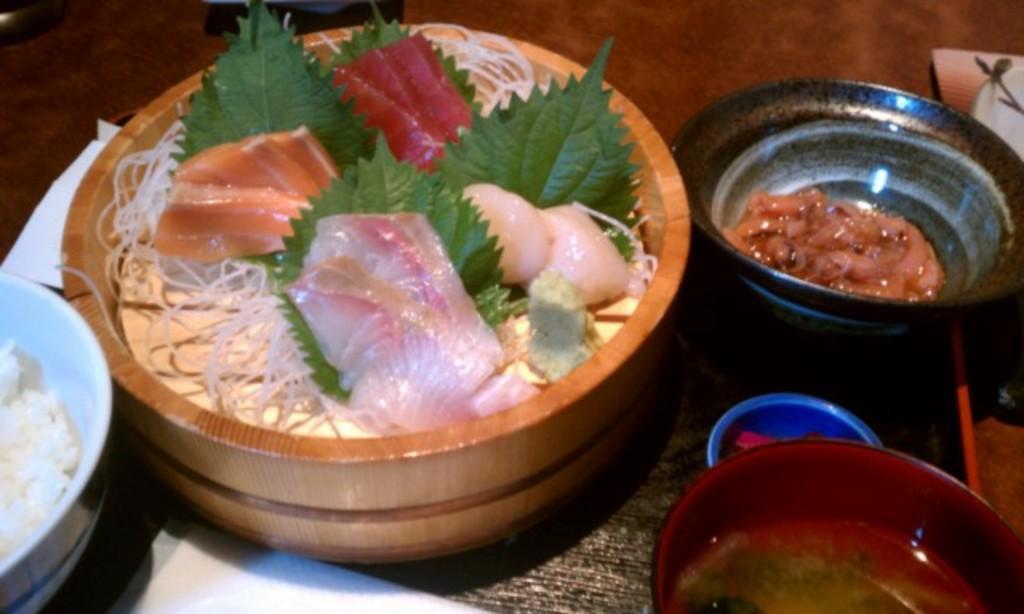Describe this image in one or two sentences. There are different containers with food in it. 